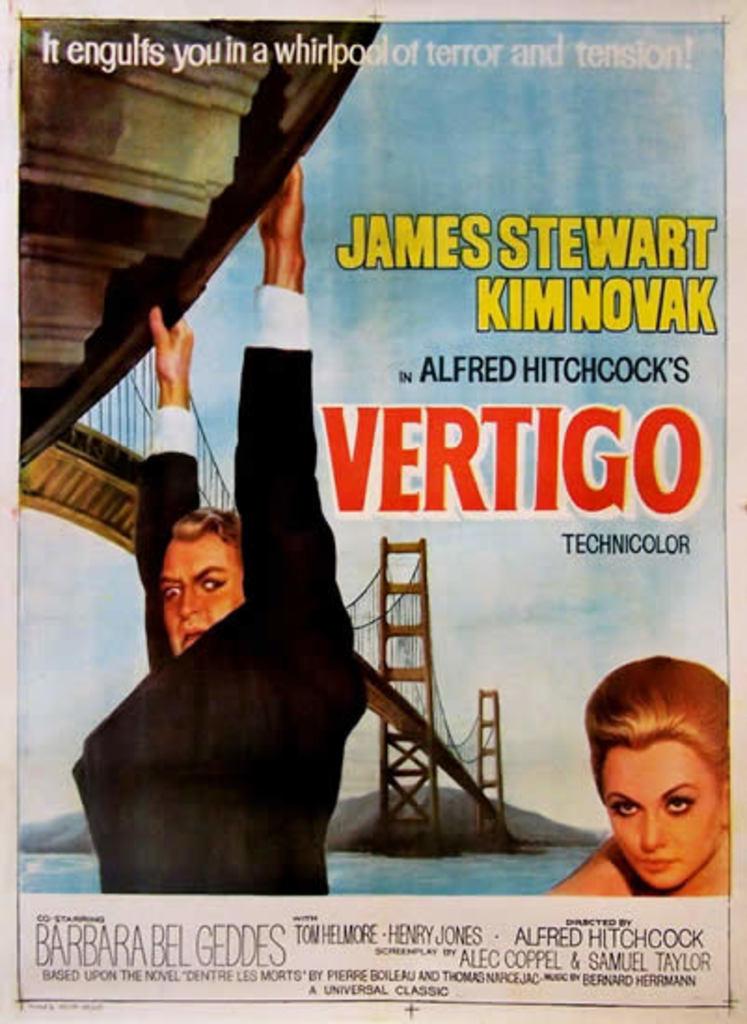What is the name of the movie on the poster?
Ensure brevity in your answer.  Vertigo. Who is in the movie?
Give a very brief answer. James stewart and kim novak. 